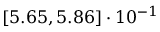Convert formula to latex. <formula><loc_0><loc_0><loc_500><loc_500>\left [ 5 . 6 5 , 5 . 8 6 \right ] \cdot 1 0 ^ { - 1 }</formula> 